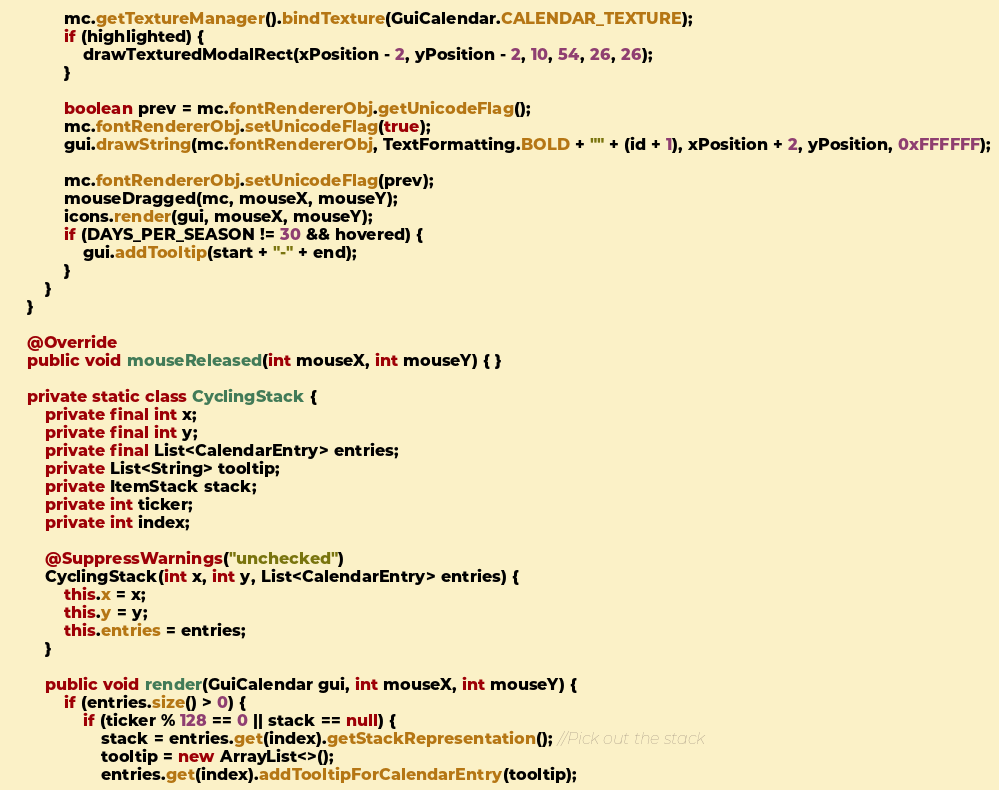<code> <loc_0><loc_0><loc_500><loc_500><_Java_>            mc.getTextureManager().bindTexture(GuiCalendar.CALENDAR_TEXTURE);
            if (highlighted) {
                drawTexturedModalRect(xPosition - 2, yPosition - 2, 10, 54, 26, 26);
            }

            boolean prev = mc.fontRendererObj.getUnicodeFlag();
            mc.fontRendererObj.setUnicodeFlag(true);
            gui.drawString(mc.fontRendererObj, TextFormatting.BOLD + "" + (id + 1), xPosition + 2, yPosition, 0xFFFFFF);

            mc.fontRendererObj.setUnicodeFlag(prev);
            mouseDragged(mc, mouseX, mouseY);
            icons.render(gui, mouseX, mouseY);
            if (DAYS_PER_SEASON != 30 && hovered) {
                gui.addTooltip(start + "-" + end);
            }
        }
    }

    @Override
    public void mouseReleased(int mouseX, int mouseY) { }

    private static class CyclingStack {
        private final int x;
        private final int y;
        private final List<CalendarEntry> entries;
        private List<String> tooltip;
        private ItemStack stack;
        private int ticker;
        private int index;

        @SuppressWarnings("unchecked")
        CyclingStack(int x, int y, List<CalendarEntry> entries) {
            this.x = x;
            this.y = y;
            this.entries = entries;
        }

        public void render(GuiCalendar gui, int mouseX, int mouseY) {
            if (entries.size() > 0) {
                if (ticker % 128 == 0 || stack == null) {
                    stack = entries.get(index).getStackRepresentation(); //Pick out the stack
                    tooltip = new ArrayList<>();
                    entries.get(index).addTooltipForCalendarEntry(tooltip);</code> 